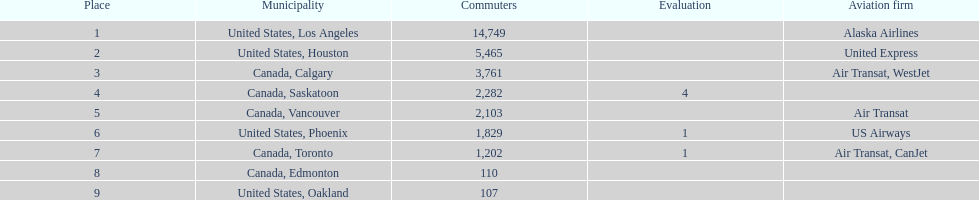What is the average number of passengers in the united states? 5537.5. 